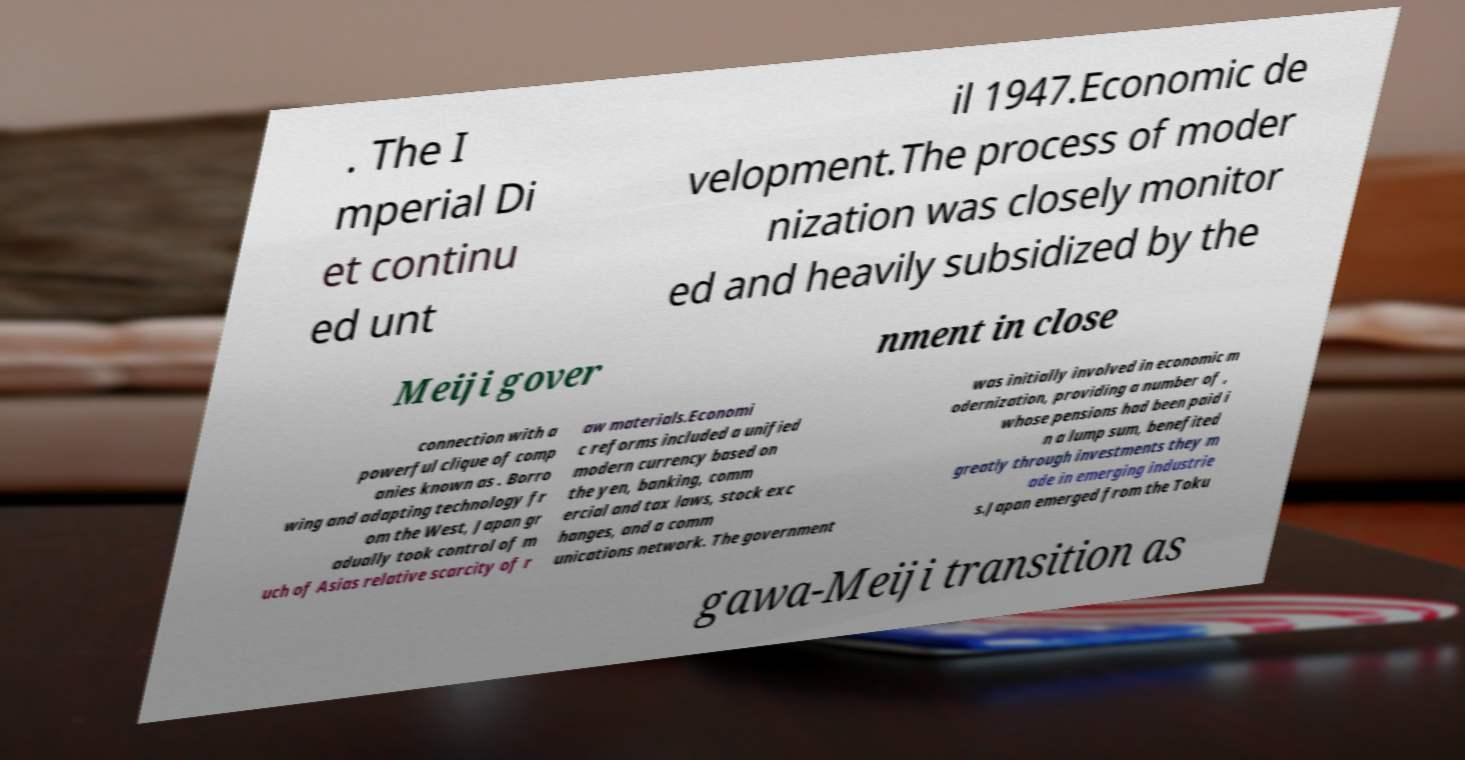Please identify and transcribe the text found in this image. . The I mperial Di et continu ed unt il 1947.Economic de velopment.The process of moder nization was closely monitor ed and heavily subsidized by the Meiji gover nment in close connection with a powerful clique of comp anies known as . Borro wing and adapting technology fr om the West, Japan gr adually took control of m uch of Asias relative scarcity of r aw materials.Economi c reforms included a unified modern currency based on the yen, banking, comm ercial and tax laws, stock exc hanges, and a comm unications network. The government was initially involved in economic m odernization, providing a number of , whose pensions had been paid i n a lump sum, benefited greatly through investments they m ade in emerging industrie s.Japan emerged from the Toku gawa-Meiji transition as 